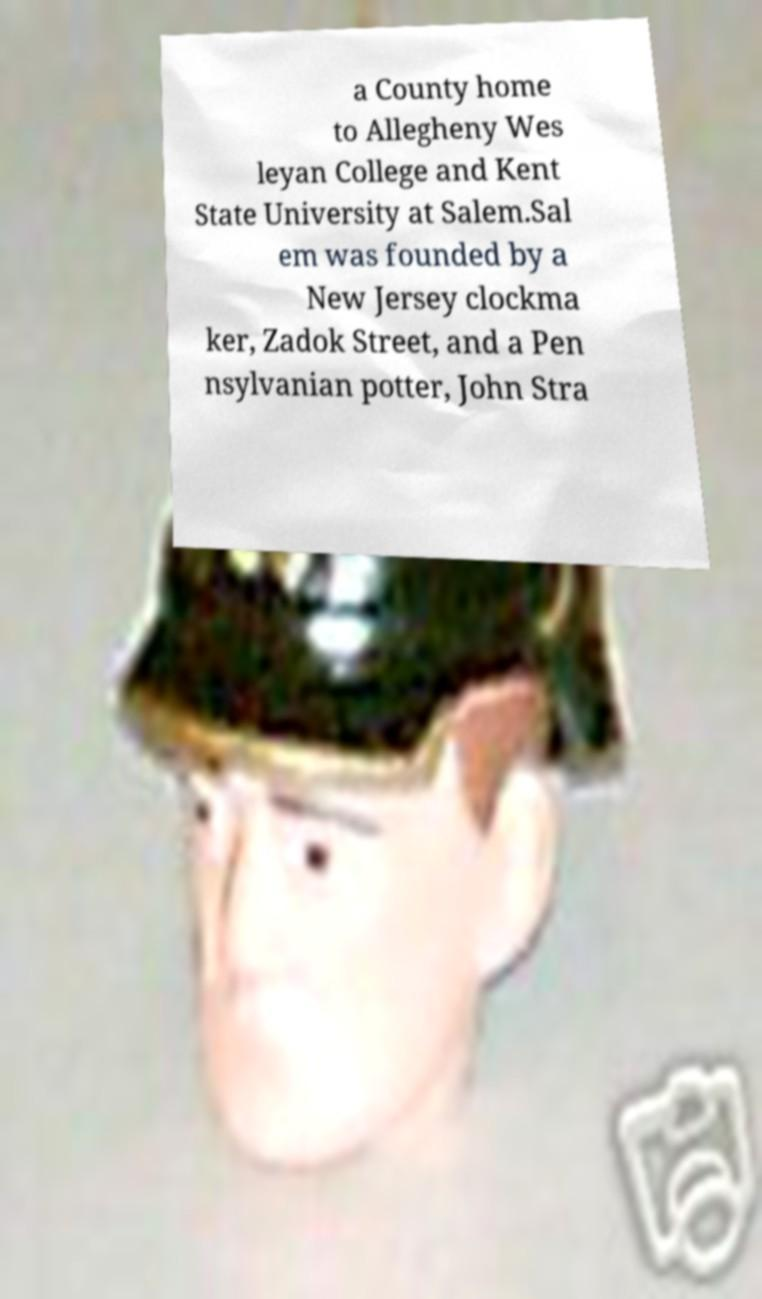Can you accurately transcribe the text from the provided image for me? a County home to Allegheny Wes leyan College and Kent State University at Salem.Sal em was founded by a New Jersey clockma ker, Zadok Street, and a Pen nsylvanian potter, John Stra 